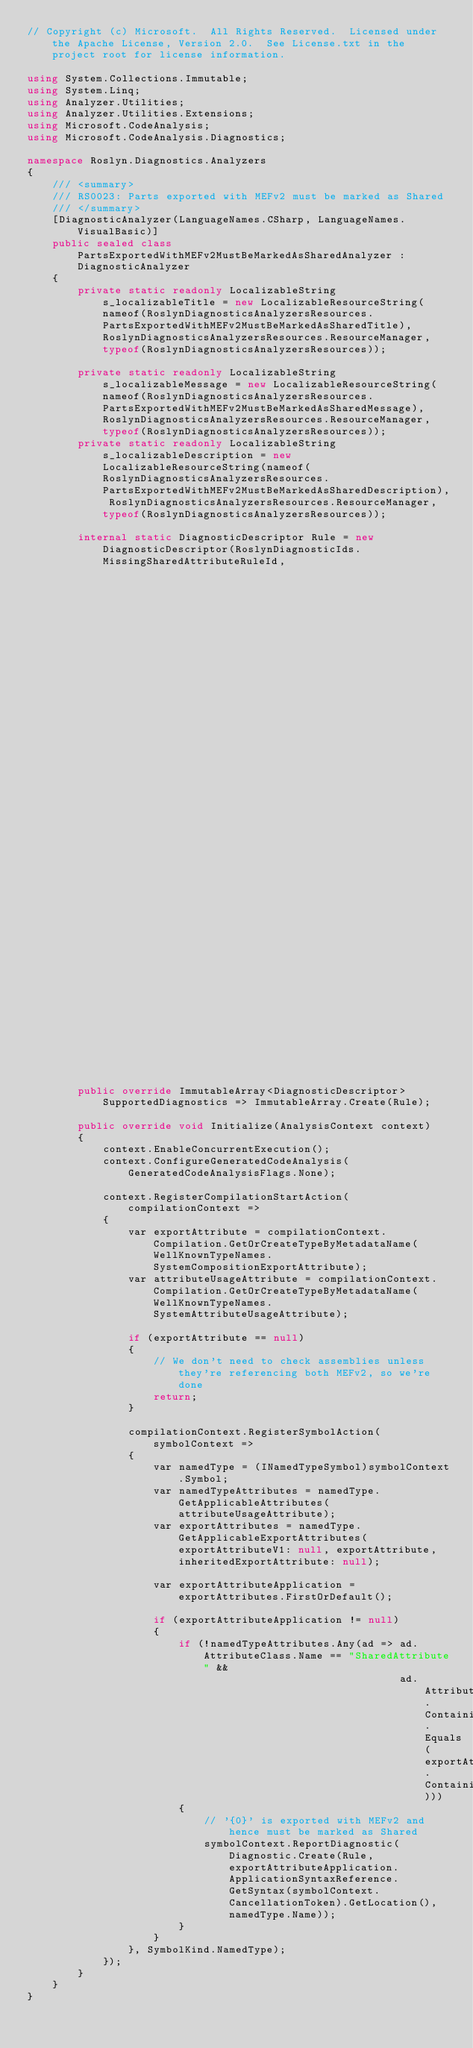Convert code to text. <code><loc_0><loc_0><loc_500><loc_500><_C#_>// Copyright (c) Microsoft.  All Rights Reserved.  Licensed under the Apache License, Version 2.0.  See License.txt in the project root for license information.

using System.Collections.Immutable;
using System.Linq;
using Analyzer.Utilities;
using Analyzer.Utilities.Extensions;
using Microsoft.CodeAnalysis;
using Microsoft.CodeAnalysis.Diagnostics;

namespace Roslyn.Diagnostics.Analyzers
{
    /// <summary>
    /// RS0023: Parts exported with MEFv2 must be marked as Shared
    /// </summary>
    [DiagnosticAnalyzer(LanguageNames.CSharp, LanguageNames.VisualBasic)]
    public sealed class PartsExportedWithMEFv2MustBeMarkedAsSharedAnalyzer : DiagnosticAnalyzer
    {
        private static readonly LocalizableString s_localizableTitle = new LocalizableResourceString(nameof(RoslynDiagnosticsAnalyzersResources.PartsExportedWithMEFv2MustBeMarkedAsSharedTitle), RoslynDiagnosticsAnalyzersResources.ResourceManager, typeof(RoslynDiagnosticsAnalyzersResources));

        private static readonly LocalizableString s_localizableMessage = new LocalizableResourceString(nameof(RoslynDiagnosticsAnalyzersResources.PartsExportedWithMEFv2MustBeMarkedAsSharedMessage), RoslynDiagnosticsAnalyzersResources.ResourceManager, typeof(RoslynDiagnosticsAnalyzersResources));
        private static readonly LocalizableString s_localizableDescription = new LocalizableResourceString(nameof(RoslynDiagnosticsAnalyzersResources.PartsExportedWithMEFv2MustBeMarkedAsSharedDescription), RoslynDiagnosticsAnalyzersResources.ResourceManager, typeof(RoslynDiagnosticsAnalyzersResources));

        internal static DiagnosticDescriptor Rule = new DiagnosticDescriptor(RoslynDiagnosticIds.MissingSharedAttributeRuleId,
                                                                             s_localizableTitle,
                                                                             s_localizableMessage,
                                                                             DiagnosticCategory.RoslynDiagnosticsReliability,
                                                                             DiagnosticSeverity.Warning,
                                                                             isEnabledByDefault: true,
                                                                             description: s_localizableDescription,
                                                                             helpLinkUri: null,
                                                                             customTags: WellKnownDiagnosticTags.Telemetry);

        public override ImmutableArray<DiagnosticDescriptor> SupportedDiagnostics => ImmutableArray.Create(Rule);

        public override void Initialize(AnalysisContext context)
        {
            context.EnableConcurrentExecution();
            context.ConfigureGeneratedCodeAnalysis(GeneratedCodeAnalysisFlags.None);

            context.RegisterCompilationStartAction(compilationContext =>
            {
                var exportAttribute = compilationContext.Compilation.GetOrCreateTypeByMetadataName(WellKnownTypeNames.SystemCompositionExportAttribute);
                var attributeUsageAttribute = compilationContext.Compilation.GetOrCreateTypeByMetadataName(WellKnownTypeNames.SystemAttributeUsageAttribute);

                if (exportAttribute == null)
                {
                    // We don't need to check assemblies unless they're referencing both MEFv2, so we're done
                    return;
                }

                compilationContext.RegisterSymbolAction(symbolContext =>
                {
                    var namedType = (INamedTypeSymbol)symbolContext.Symbol;
                    var namedTypeAttributes = namedType.GetApplicableAttributes(attributeUsageAttribute);
                    var exportAttributes = namedType.GetApplicableExportAttributes(exportAttributeV1: null, exportAttribute, inheritedExportAttribute: null);

                    var exportAttributeApplication = exportAttributes.FirstOrDefault();

                    if (exportAttributeApplication != null)
                    {
                        if (!namedTypeAttributes.Any(ad => ad.AttributeClass.Name == "SharedAttribute" &&
                                                           ad.AttributeClass.ContainingNamespace.Equals(exportAttribute.ContainingNamespace)))
                        {
                            // '{0}' is exported with MEFv2 and hence must be marked as Shared
                            symbolContext.ReportDiagnostic(Diagnostic.Create(Rule, exportAttributeApplication.ApplicationSyntaxReference.GetSyntax(symbolContext.CancellationToken).GetLocation(), namedType.Name));
                        }
                    }
                }, SymbolKind.NamedType);
            });
        }
    }
}</code> 